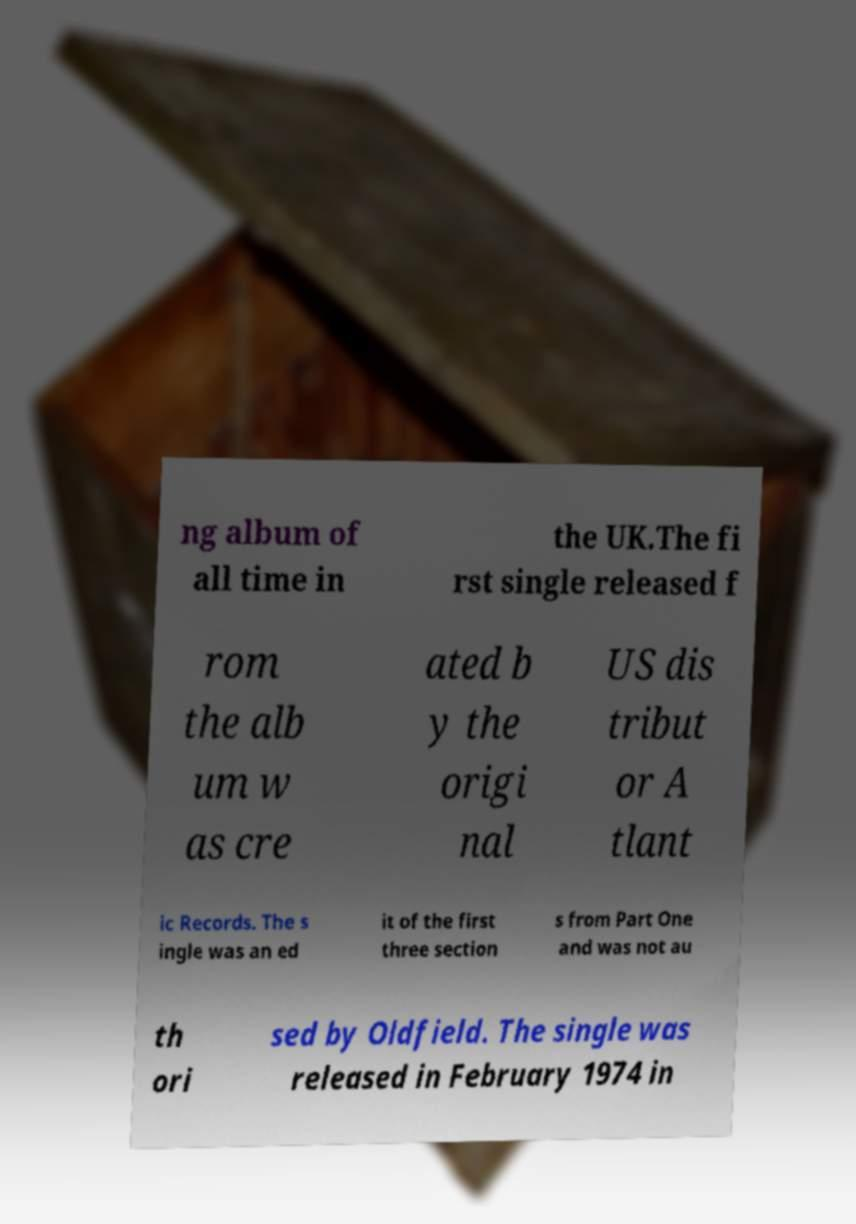Can you accurately transcribe the text from the provided image for me? ng album of all time in the UK.The fi rst single released f rom the alb um w as cre ated b y the origi nal US dis tribut or A tlant ic Records. The s ingle was an ed it of the first three section s from Part One and was not au th ori sed by Oldfield. The single was released in February 1974 in 